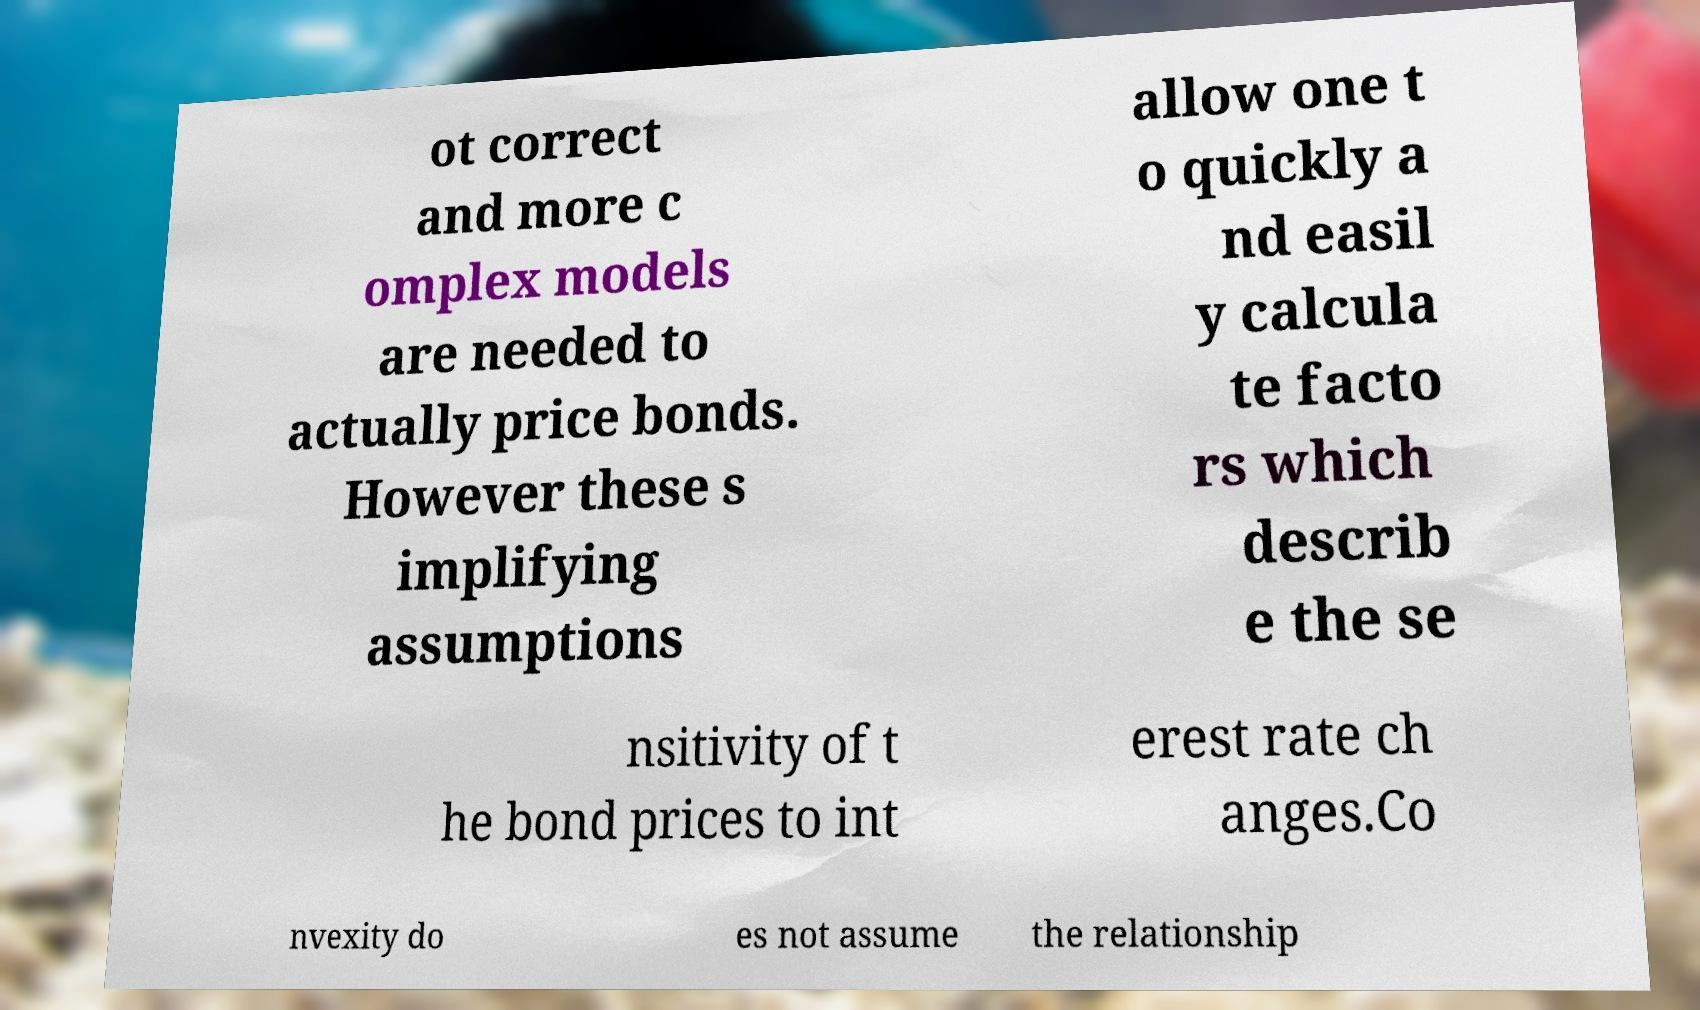Can you read and provide the text displayed in the image?This photo seems to have some interesting text. Can you extract and type it out for me? ot correct and more c omplex models are needed to actually price bonds. However these s implifying assumptions allow one t o quickly a nd easil y calcula te facto rs which describ e the se nsitivity of t he bond prices to int erest rate ch anges.Co nvexity do es not assume the relationship 